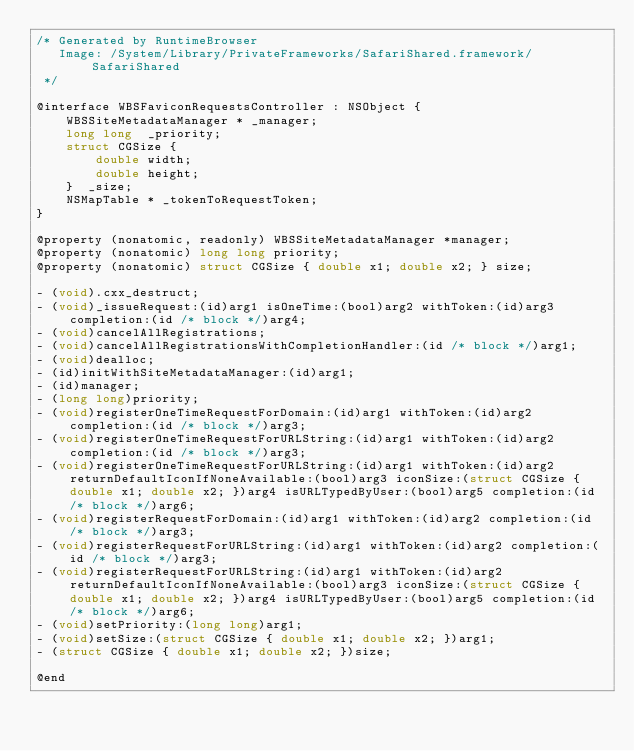Convert code to text. <code><loc_0><loc_0><loc_500><loc_500><_C_>/* Generated by RuntimeBrowser
   Image: /System/Library/PrivateFrameworks/SafariShared.framework/SafariShared
 */

@interface WBSFaviconRequestsController : NSObject {
    WBSSiteMetadataManager * _manager;
    long long  _priority;
    struct CGSize { 
        double width; 
        double height; 
    }  _size;
    NSMapTable * _tokenToRequestToken;
}

@property (nonatomic, readonly) WBSSiteMetadataManager *manager;
@property (nonatomic) long long priority;
@property (nonatomic) struct CGSize { double x1; double x2; } size;

- (void).cxx_destruct;
- (void)_issueRequest:(id)arg1 isOneTime:(bool)arg2 withToken:(id)arg3 completion:(id /* block */)arg4;
- (void)cancelAllRegistrations;
- (void)cancelAllRegistrationsWithCompletionHandler:(id /* block */)arg1;
- (void)dealloc;
- (id)initWithSiteMetadataManager:(id)arg1;
- (id)manager;
- (long long)priority;
- (void)registerOneTimeRequestForDomain:(id)arg1 withToken:(id)arg2 completion:(id /* block */)arg3;
- (void)registerOneTimeRequestForURLString:(id)arg1 withToken:(id)arg2 completion:(id /* block */)arg3;
- (void)registerOneTimeRequestForURLString:(id)arg1 withToken:(id)arg2 returnDefaultIconIfNoneAvailable:(bool)arg3 iconSize:(struct CGSize { double x1; double x2; })arg4 isURLTypedByUser:(bool)arg5 completion:(id /* block */)arg6;
- (void)registerRequestForDomain:(id)arg1 withToken:(id)arg2 completion:(id /* block */)arg3;
- (void)registerRequestForURLString:(id)arg1 withToken:(id)arg2 completion:(id /* block */)arg3;
- (void)registerRequestForURLString:(id)arg1 withToken:(id)arg2 returnDefaultIconIfNoneAvailable:(bool)arg3 iconSize:(struct CGSize { double x1; double x2; })arg4 isURLTypedByUser:(bool)arg5 completion:(id /* block */)arg6;
- (void)setPriority:(long long)arg1;
- (void)setSize:(struct CGSize { double x1; double x2; })arg1;
- (struct CGSize { double x1; double x2; })size;

@end
</code> 